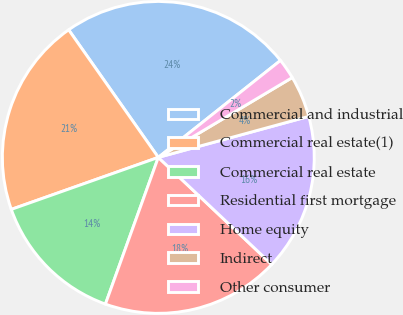<chart> <loc_0><loc_0><loc_500><loc_500><pie_chart><fcel>Commercial and industrial<fcel>Commercial real estate(1)<fcel>Commercial real estate<fcel>Residential first mortgage<fcel>Home equity<fcel>Indirect<fcel>Other consumer<nl><fcel>24.07%<fcel>20.66%<fcel>14.08%<fcel>18.47%<fcel>16.27%<fcel>4.32%<fcel>2.12%<nl></chart> 